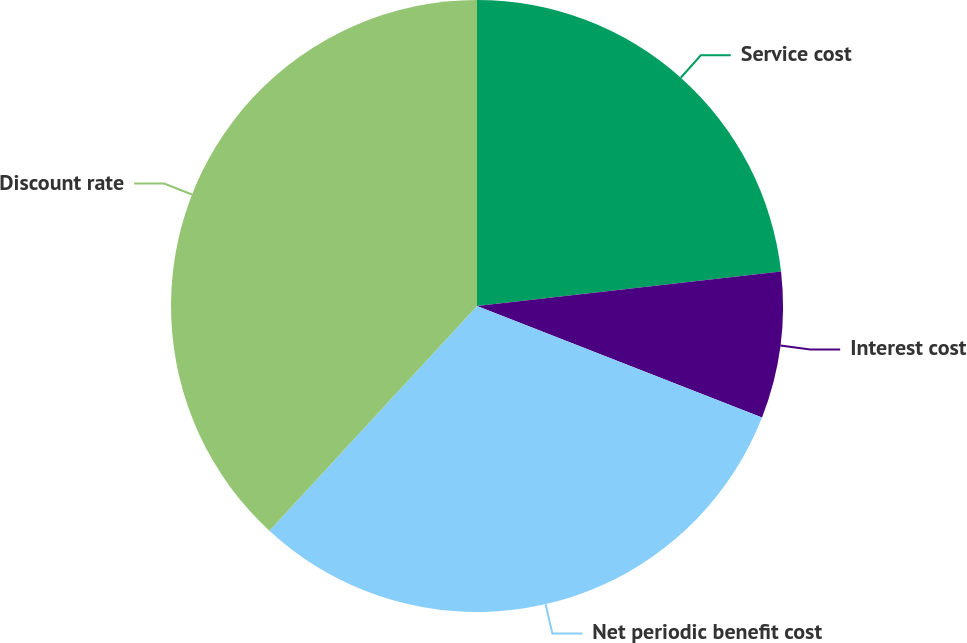Convert chart to OTSL. <chart><loc_0><loc_0><loc_500><loc_500><pie_chart><fcel>Service cost<fcel>Interest cost<fcel>Net periodic benefit cost<fcel>Discount rate<nl><fcel>23.2%<fcel>7.73%<fcel>30.94%<fcel>38.13%<nl></chart> 